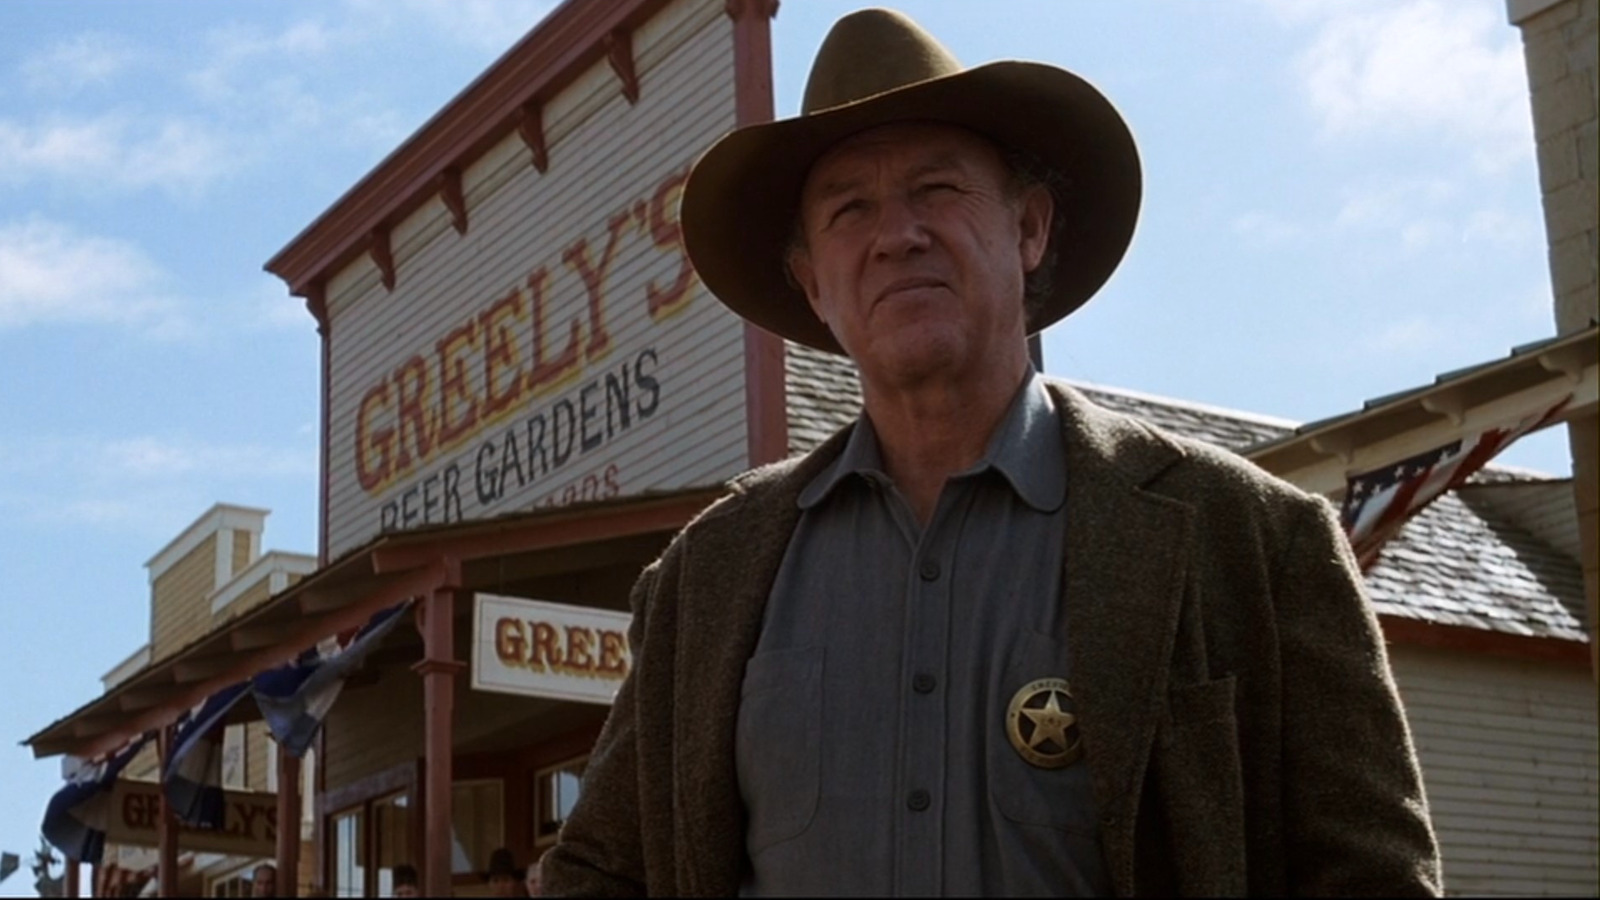What do you see happening in this image? The image shows a person standing in front of a building with a sign that reads 'Greenly's Beer Gardens.' The individual is dressed in attire that suggests a thematic costume, possibly evocative of the old west. They are wearing a cowboy hat, a jacket, and what appears to be a badge on their lapel. The atmosphere of the photo hints at a historical or thematic recreation, such as a movie set, theme park, or a costume event. The person's expression is serious, and they are looking off to the side, which could indicate a posed photo intending to convey a narrative or character. 